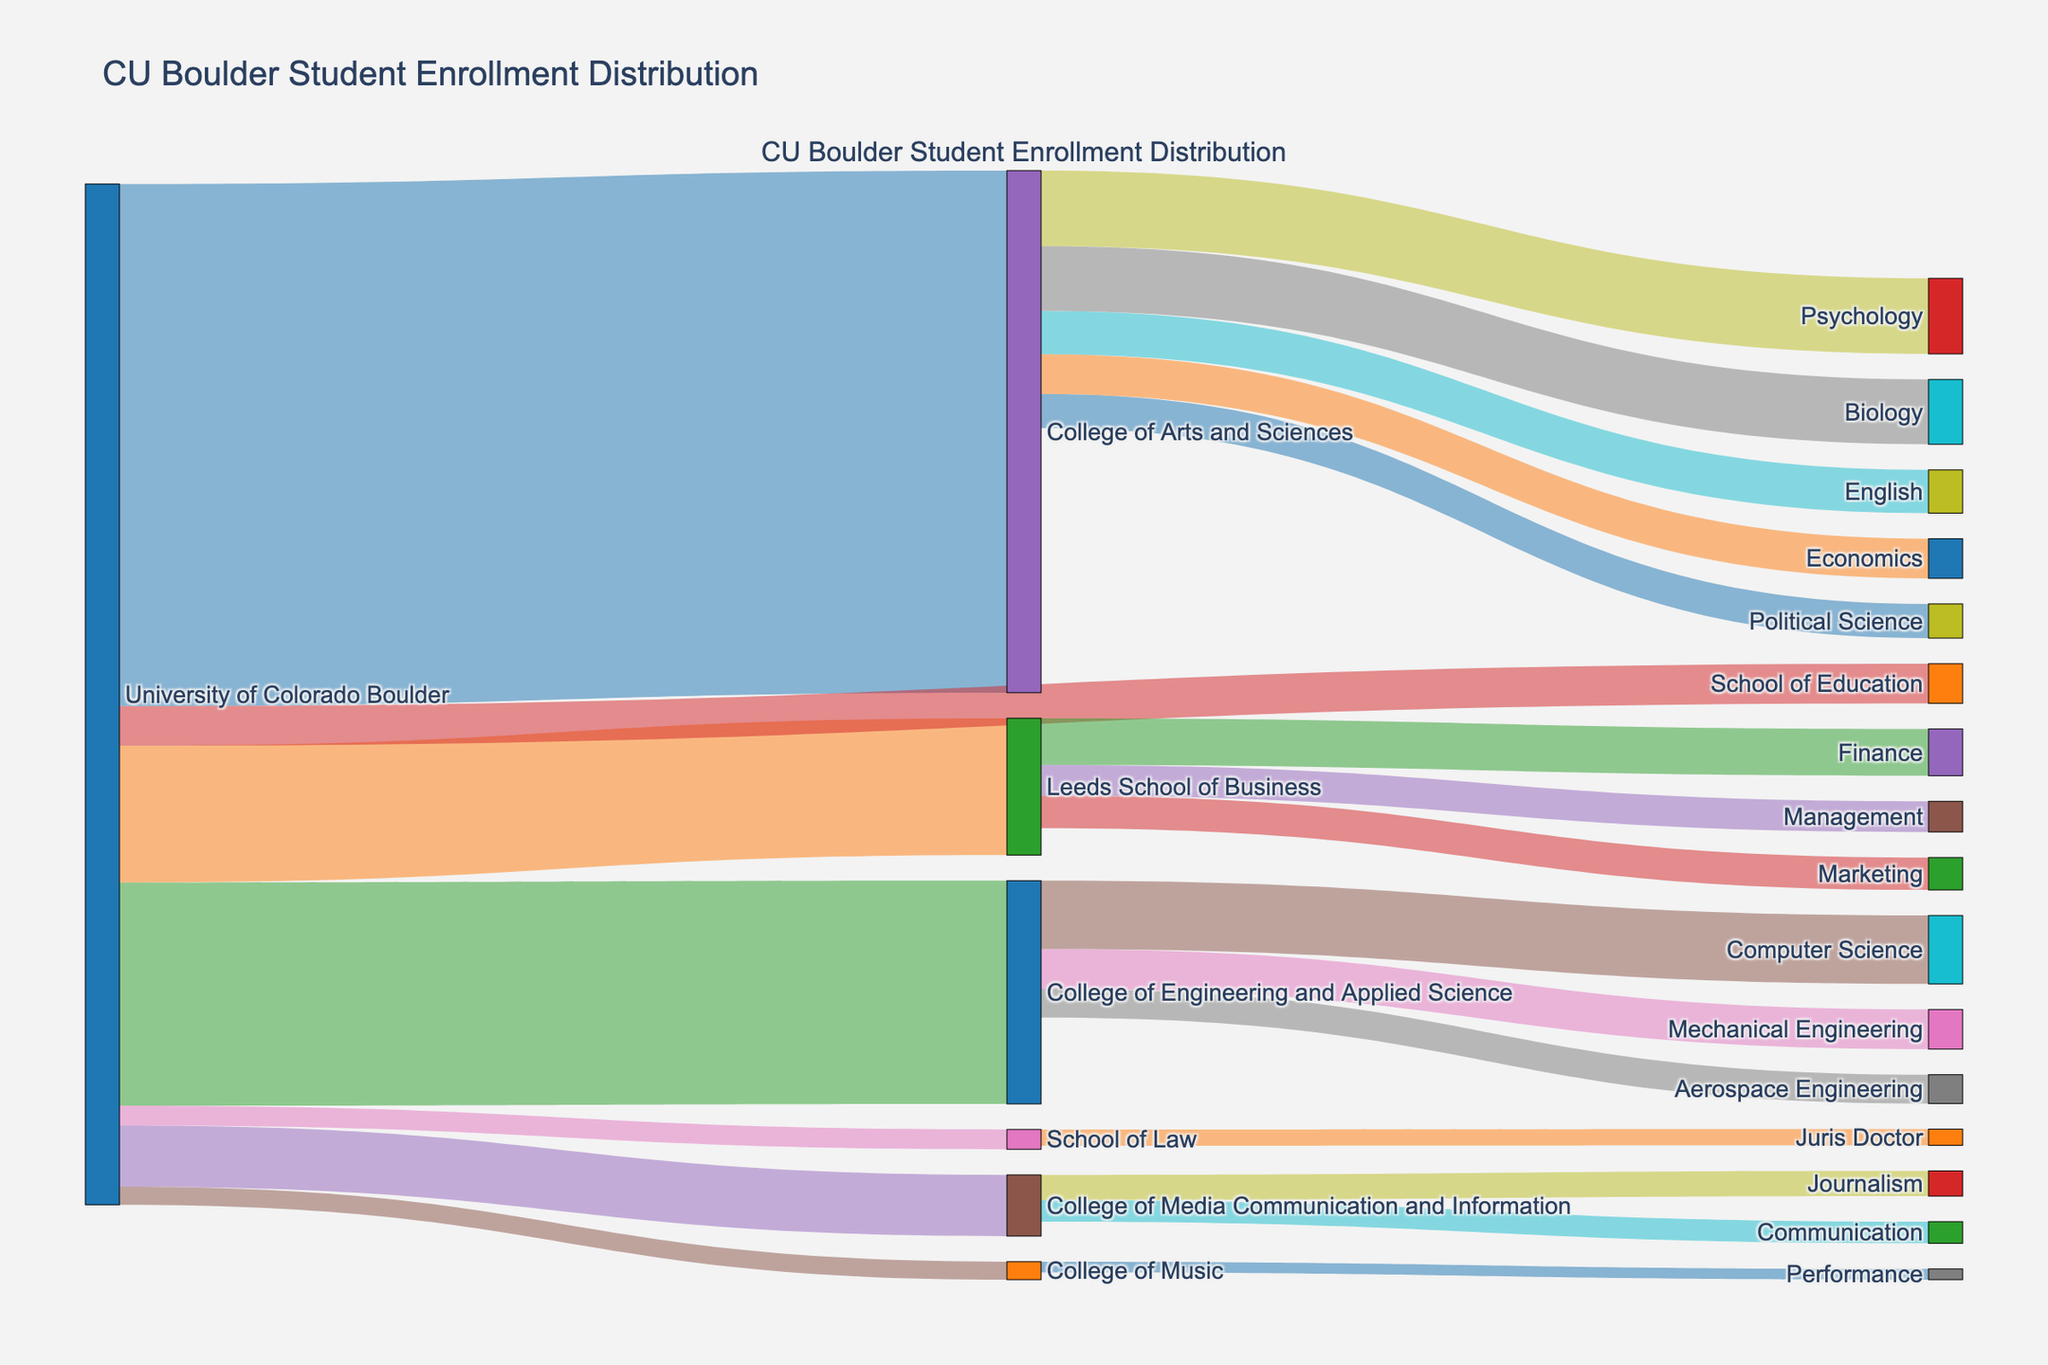Which college has the highest student enrollment at the University of Colorado Boulder? Look at the Sankey diagram where the width of the flow lines represents the number of students. The widest flow line from the "University of Colorado Boulder" corresponds to the "College of Arts and Sciences".
Answer: College of Arts and Sciences What is the total number of students enrolled in the Computer Science major? Identify the flow line starting from the "College of Engineering and Applied Science" to "Computer Science". The value shown is 1900.
Answer: 1900 How many students are enrolled in the Leeds School of Business? Check the flow line connecting "University of Colorado Boulder" with "Leeds School of Business". The number is 3800.
Answer: 3800 Which has more students: the College of Music or the School of Law? Compare the flow lines from "University of Colorado Boulder" to "College of Music" and "School of Law". College of Music has 500 students, and School of Law has 550.
Answer: School of Law What is the total enrollment for majors under the College of Arts and Sciences? Sum the student numbers of all majors within the College of Arts and Sciences. The numbers are: Biology (1800), Psychology (2100), English (1200), Political Science (950), and Economics (1100). This sums to 7150.
Answer: 7150 How does the enrollment in Mechanical Engineering compare to Aerospace Engineering? Locate the flow lines from "College of Engineering and Applied Science" to "Mechanical Engineering" and "Aerospace Engineering". Mechanical Engineering has 1100 students, whereas Aerospace Engineering has 800 students.
Answer: Mechanical Engineering has more students What is the least populated major in the College of Arts and Sciences? Identify the majors within the College of Arts and Sciences and find the one with the smallest number. The numbers are: Biology (1800), Psychology (2100), English (1200), Political Science (950), and Economics (1100). Political Science has the smallest value, 950.
Answer: Political Science How many more students are enrolled in the Finance major compared to Marketing in the Leeds School of Business? From the flow lines, Finance has 1300 students, and Marketing has 900. The difference is 1300 - 900 = 400.
Answer: 400 What portion of the College of Engineering and Applied Science students are in Computer Science? Out of the total 6200 students in the College of Engineering and Applied Science, 1900 are in Computer Science. The percentage is (1900 / 6200) * 100 = 30.65%.
Answer: 30.65% Which college has the smallest student enrollment at CU Boulder? Compare the flow lines originating from "University of Colorado Boulder" with each college. The one with the smallest number is "College of Music" with 500 students.
Answer: College of Music 